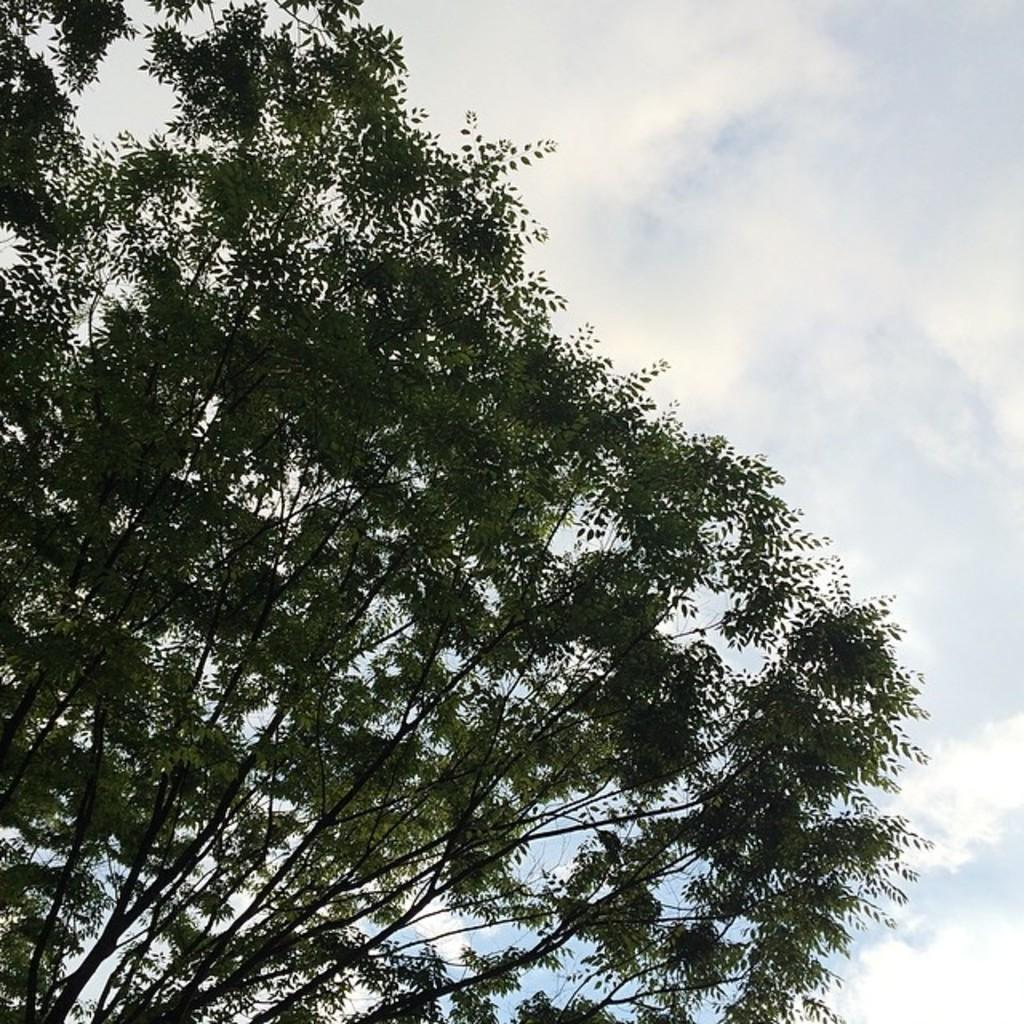What type of vegetation is present in the image? There is a tree in the image. What is visible at the top of the image? The sky is visible at the top of the image. Where is the family mark located in the image? There is no family mark present in the image. How many houses can be seen in the image? There are no houses visible in the image; it only features a tree and the sky. 